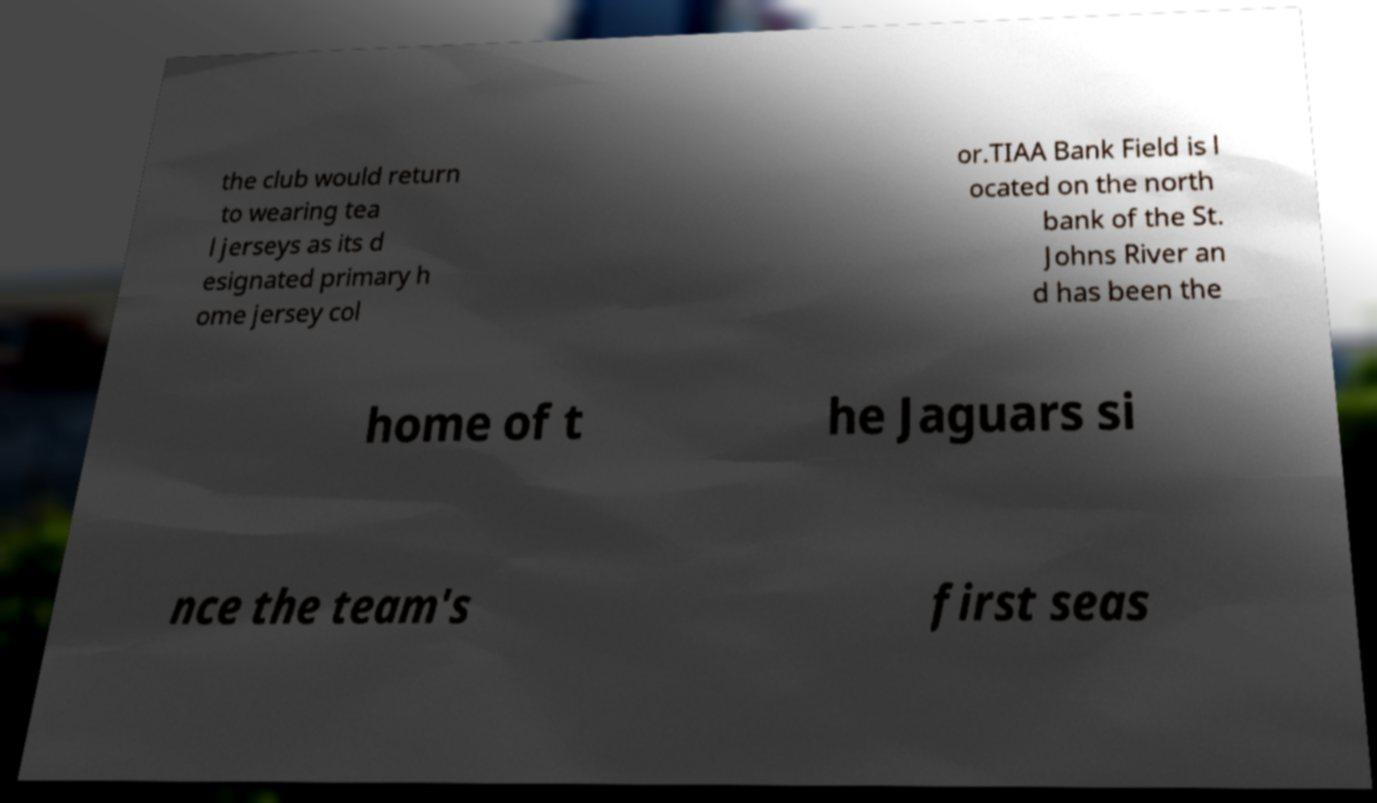Could you assist in decoding the text presented in this image and type it out clearly? the club would return to wearing tea l jerseys as its d esignated primary h ome jersey col or.TIAA Bank Field is l ocated on the north bank of the St. Johns River an d has been the home of t he Jaguars si nce the team's first seas 